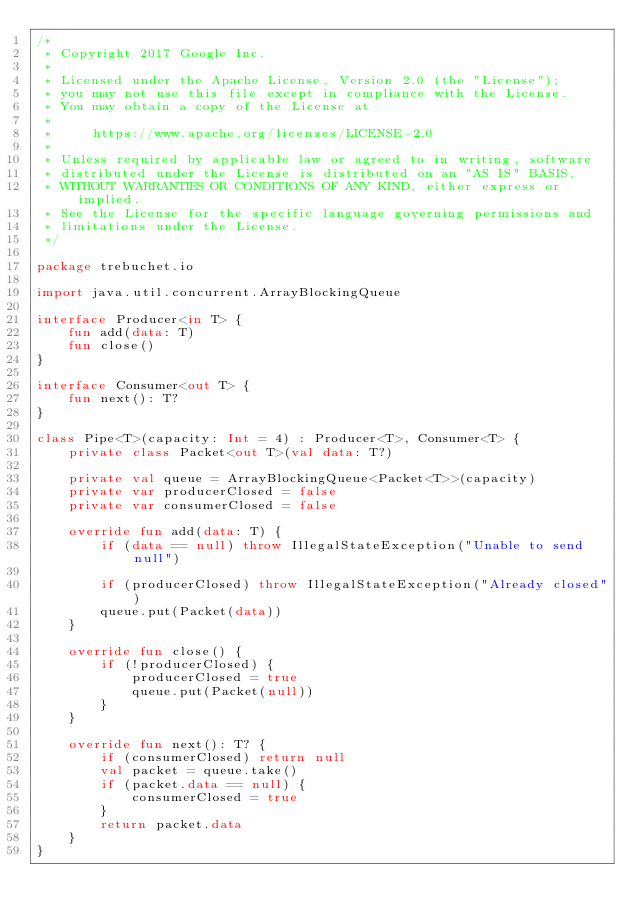<code> <loc_0><loc_0><loc_500><loc_500><_Kotlin_>/*
 * Copyright 2017 Google Inc.
 *
 * Licensed under the Apache License, Version 2.0 (the "License");
 * you may not use this file except in compliance with the License.
 * You may obtain a copy of the License at
 *
 *     https://www.apache.org/licenses/LICENSE-2.0
 *
 * Unless required by applicable law or agreed to in writing, software
 * distributed under the License is distributed on an "AS IS" BASIS,
 * WITHOUT WARRANTIES OR CONDITIONS OF ANY KIND, either express or implied.
 * See the License for the specific language governing permissions and
 * limitations under the License.
 */

package trebuchet.io

import java.util.concurrent.ArrayBlockingQueue

interface Producer<in T> {
    fun add(data: T)
    fun close()
}

interface Consumer<out T> {
    fun next(): T?
}

class Pipe<T>(capacity: Int = 4) : Producer<T>, Consumer<T> {
    private class Packet<out T>(val data: T?)

    private val queue = ArrayBlockingQueue<Packet<T>>(capacity)
    private var producerClosed = false
    private var consumerClosed = false

    override fun add(data: T) {
        if (data == null) throw IllegalStateException("Unable to send null")

        if (producerClosed) throw IllegalStateException("Already closed")
        queue.put(Packet(data))
    }

    override fun close() {
        if (!producerClosed) {
            producerClosed = true
            queue.put(Packet(null))
        }
    }

    override fun next(): T? {
        if (consumerClosed) return null
        val packet = queue.take()
        if (packet.data == null) {
            consumerClosed = true
        }
        return packet.data
    }
}</code> 